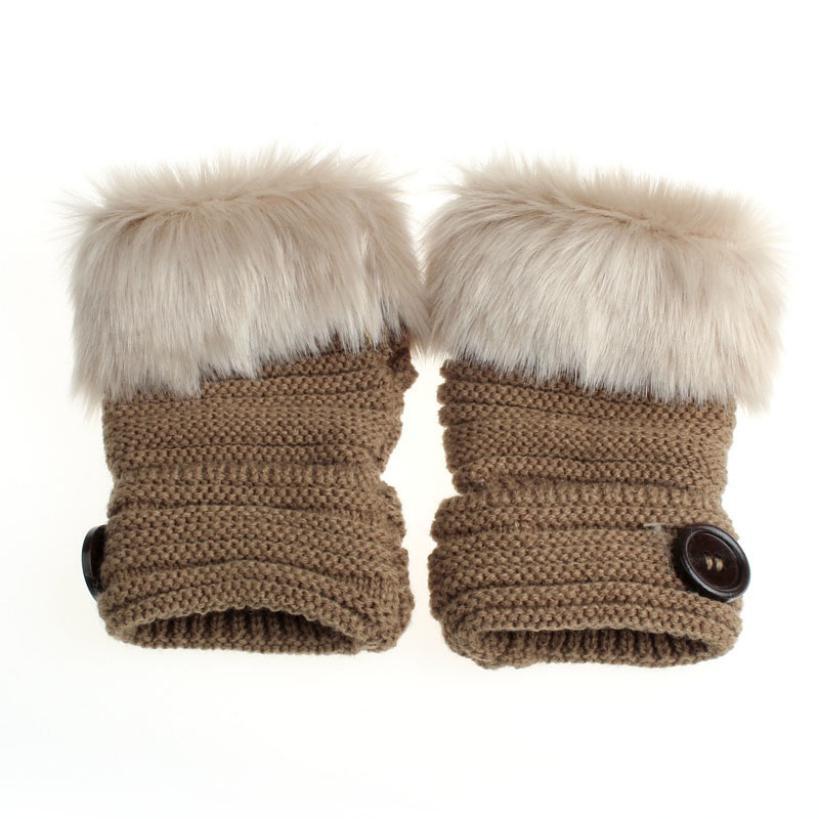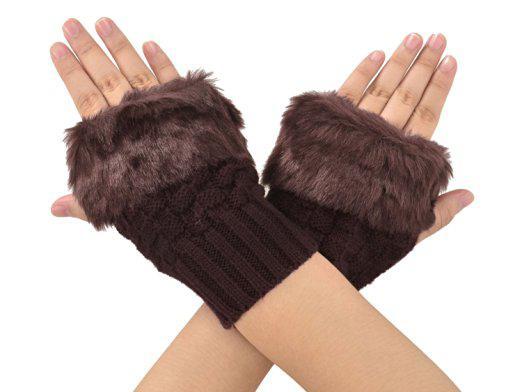The first image is the image on the left, the second image is the image on the right. Analyze the images presented: Is the assertion "A dark brown pair of gloves are worn by a human hand." valid? Answer yes or no. Yes. The first image is the image on the left, the second image is the image on the right. Analyze the images presented: Is the assertion "One image shows human hands wearing gloves, and one shows a pair of unworn gloves." valid? Answer yes or no. Yes. 